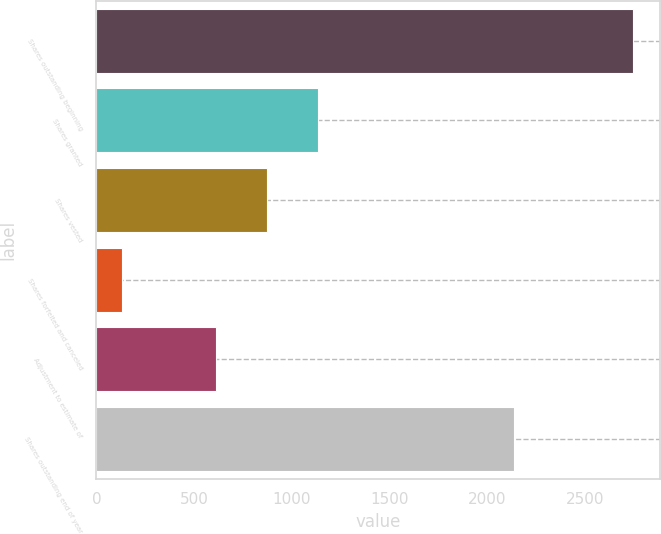Convert chart. <chart><loc_0><loc_0><loc_500><loc_500><bar_chart><fcel>Shares outstanding beginning<fcel>Shares granted<fcel>Shares vested<fcel>Shares forfeited and canceled<fcel>Adjustment to estimate of<fcel>Shares outstanding end of year<nl><fcel>2747<fcel>1134.4<fcel>872.7<fcel>130<fcel>611<fcel>2140<nl></chart> 